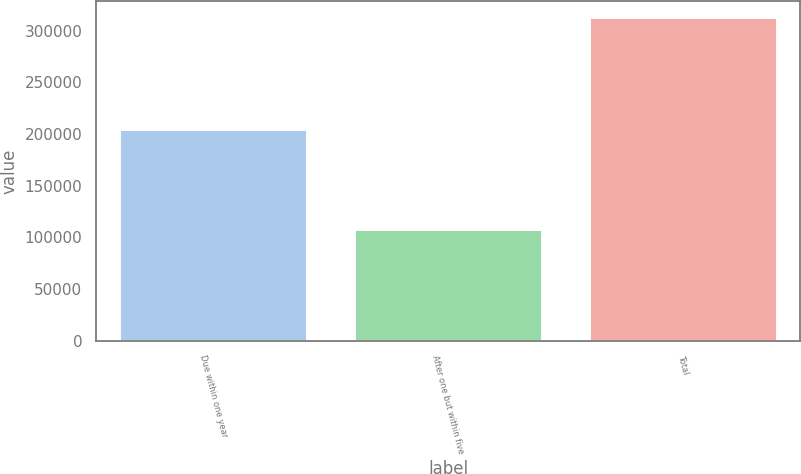Convert chart to OTSL. <chart><loc_0><loc_0><loc_500><loc_500><bar_chart><fcel>Due within one year<fcel>After one but within five<fcel>Total<nl><fcel>204774<fcel>108277<fcel>313051<nl></chart> 